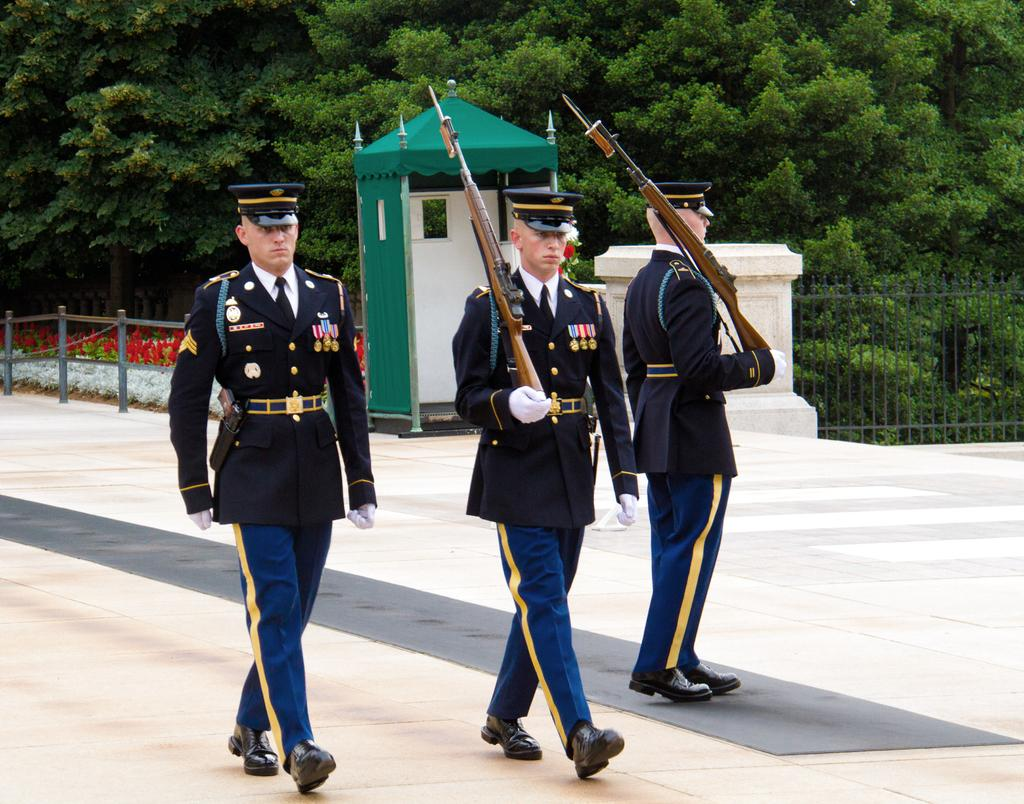How many people are present in the image? There are three people in the image. What are two of the people holding? Two of the people are holding guns. What can be seen in the background of the image? There are fences, trees, plants, a shed, and an unspecified object in the background of the image. What type of friction can be observed between the neck and the button in the image? There is no neck or button present in the image, so no such friction can be observed. 